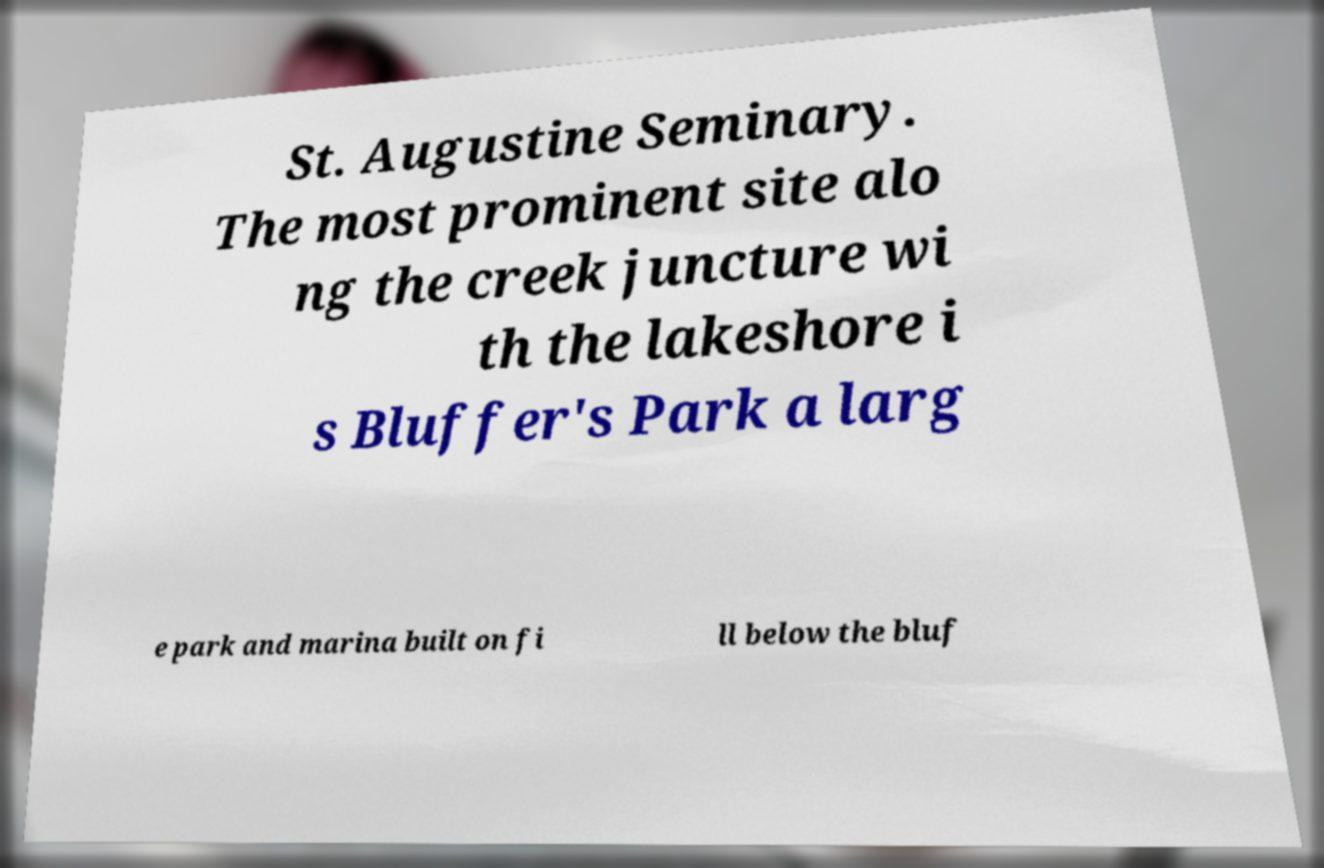Could you extract and type out the text from this image? St. Augustine Seminary. The most prominent site alo ng the creek juncture wi th the lakeshore i s Bluffer's Park a larg e park and marina built on fi ll below the bluf 